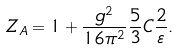<formula> <loc_0><loc_0><loc_500><loc_500>Z _ { A } = 1 + \frac { g ^ { 2 } } { 1 6 \pi ^ { 2 } } \frac { 5 } { 3 } C \frac { 2 } { \varepsilon } .</formula> 